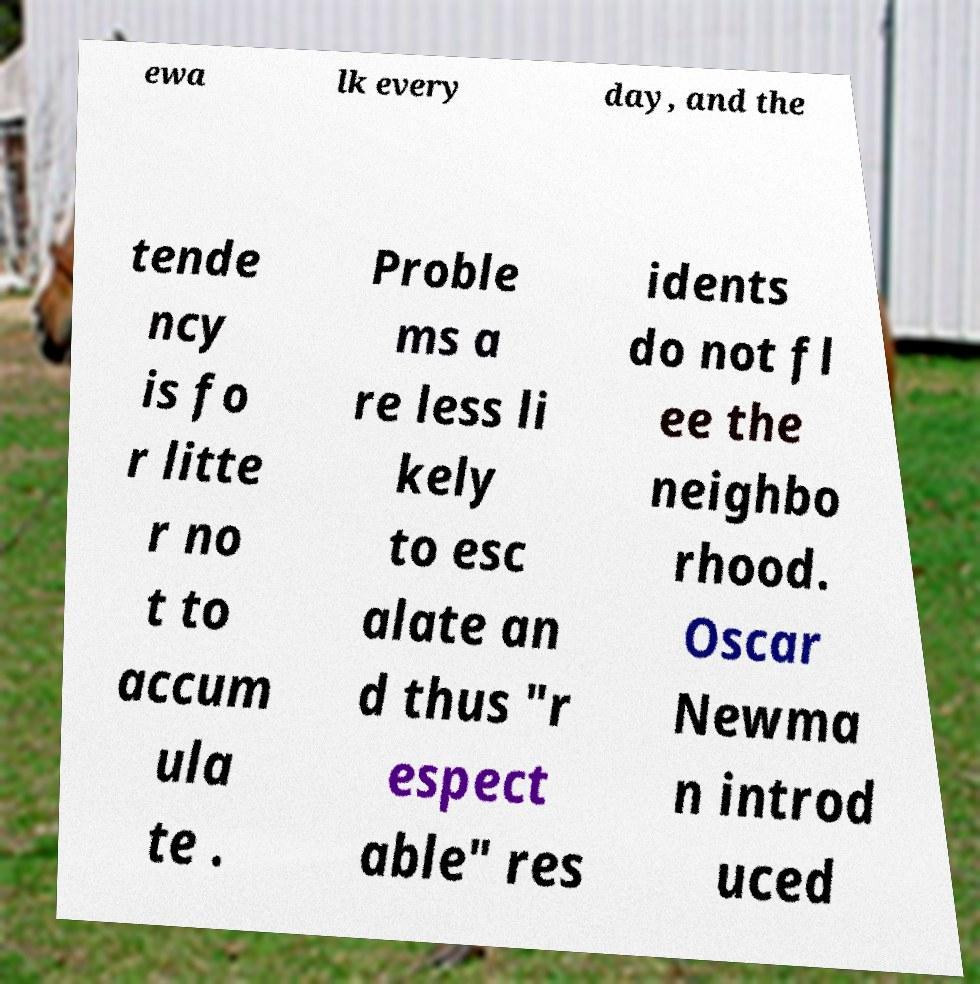Can you accurately transcribe the text from the provided image for me? ewa lk every day, and the tende ncy is fo r litte r no t to accum ula te . Proble ms a re less li kely to esc alate an d thus "r espect able" res idents do not fl ee the neighbo rhood. Oscar Newma n introd uced 